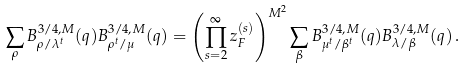<formula> <loc_0><loc_0><loc_500><loc_500>\sum _ { \rho } B ^ { 3 / 4 , M } _ { \rho / \lambda ^ { t } } ( q ) B ^ { 3 / 4 , M } _ { \rho ^ { t } / \mu } ( q ) = \left ( \prod _ { s = 2 } ^ { \infty } z _ { F } ^ { ( s ) } \right ) ^ { M ^ { 2 } } \sum _ { \beta } B ^ { 3 / 4 , M } _ { \mu ^ { t } / \beta ^ { t } } ( q ) B ^ { 3 / 4 , M } _ { \lambda / \beta } ( q ) \, .</formula> 